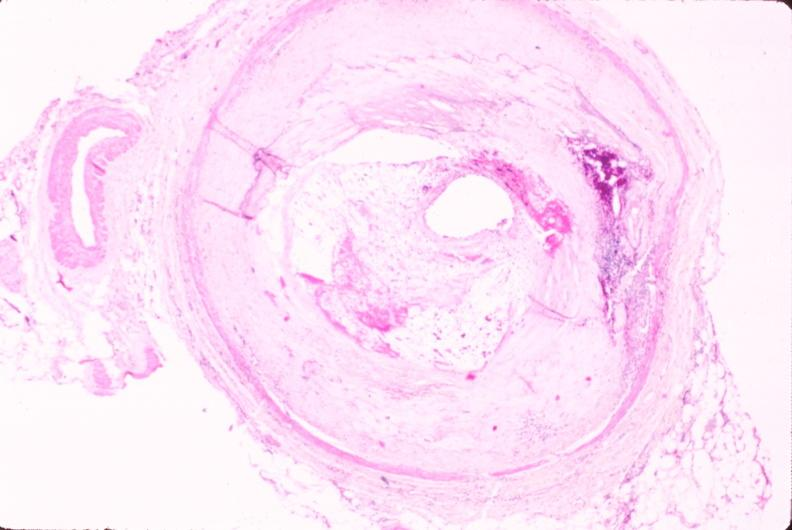does this section showing liver with tumor mass in hilar area tumor show atherosclerosis?
Answer the question using a single word or phrase. No 